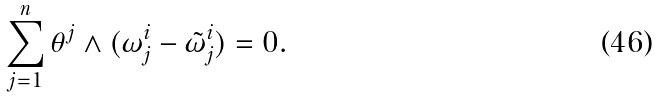<formula> <loc_0><loc_0><loc_500><loc_500>\sum _ { j = 1 } ^ { n } \theta ^ { j } \land ( \omega _ { j } ^ { i } - \tilde { \omega } _ { j } ^ { i } ) = 0 .</formula> 